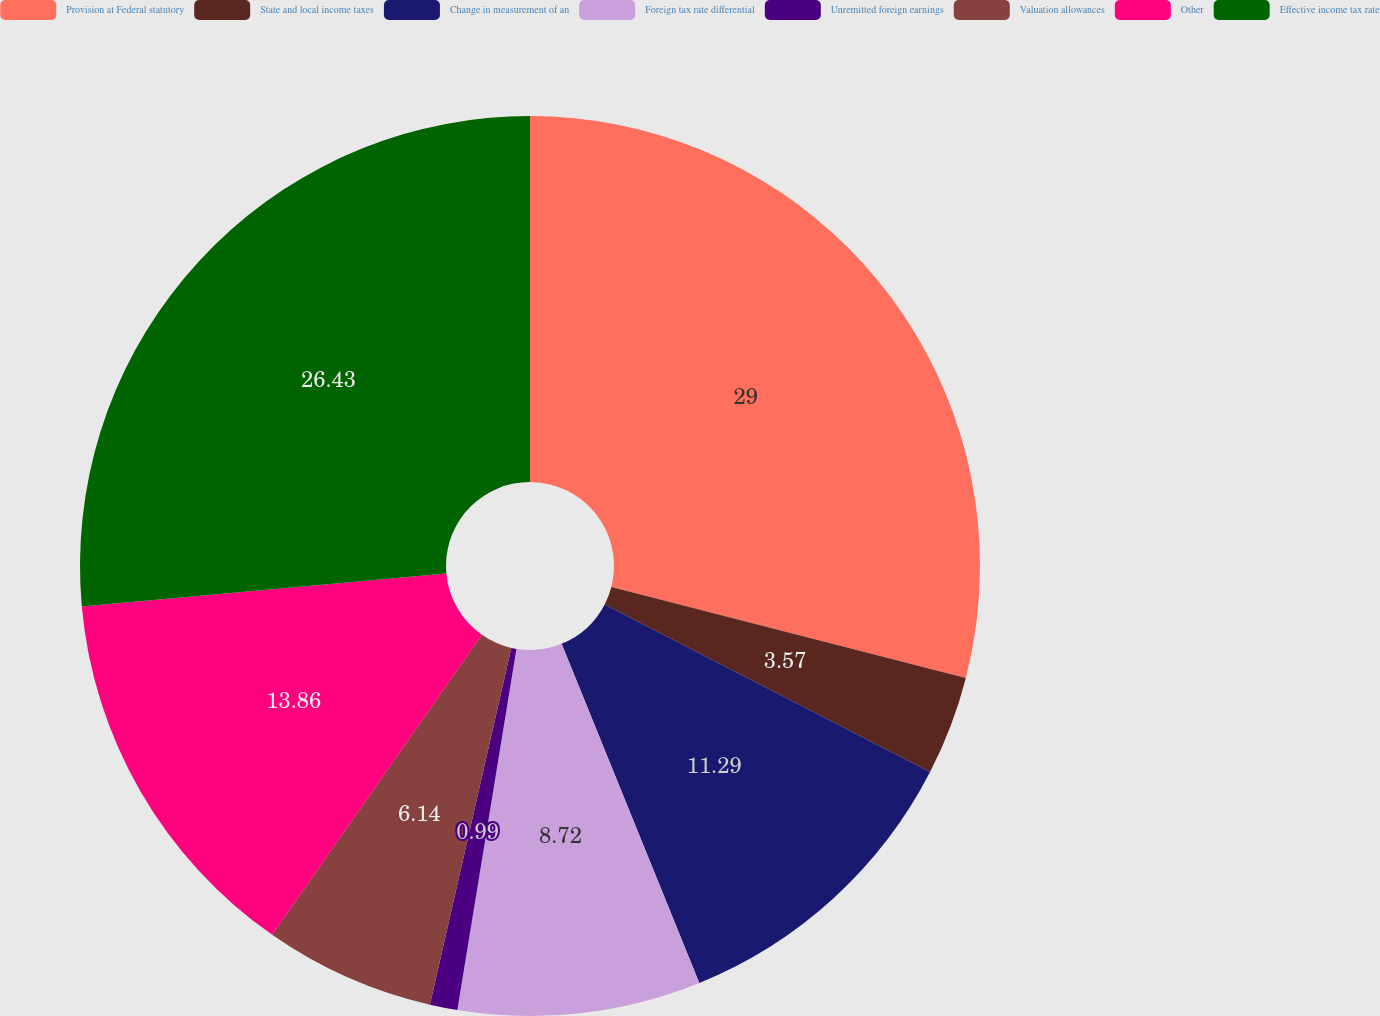Convert chart to OTSL. <chart><loc_0><loc_0><loc_500><loc_500><pie_chart><fcel>Provision at Federal statutory<fcel>State and local income taxes<fcel>Change in measurement of an<fcel>Foreign tax rate differential<fcel>Unremitted foreign earnings<fcel>Valuation allowances<fcel>Other<fcel>Effective income tax rate<nl><fcel>29.0%<fcel>3.57%<fcel>11.29%<fcel>8.72%<fcel>0.99%<fcel>6.14%<fcel>13.86%<fcel>26.43%<nl></chart> 